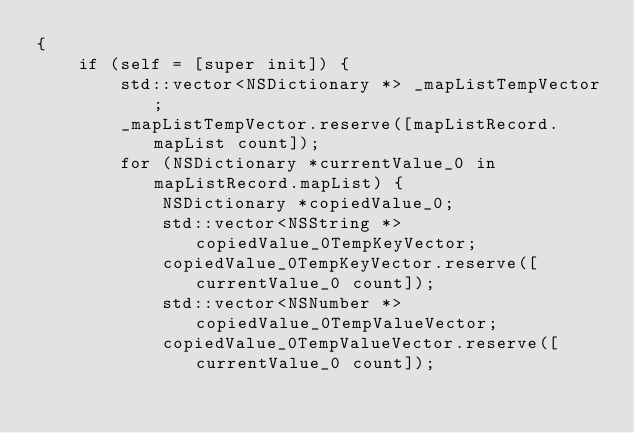<code> <loc_0><loc_0><loc_500><loc_500><_ObjectiveC_>{
    if (self = [super init]) {
        std::vector<NSDictionary *> _mapListTempVector;
        _mapListTempVector.reserve([mapListRecord.mapList count]);
        for (NSDictionary *currentValue_0 in mapListRecord.mapList) {
            NSDictionary *copiedValue_0;
            std::vector<NSString *> copiedValue_0TempKeyVector;
            copiedValue_0TempKeyVector.reserve([currentValue_0 count]);
            std::vector<NSNumber *> copiedValue_0TempValueVector;
            copiedValue_0TempValueVector.reserve([currentValue_0 count]);</code> 